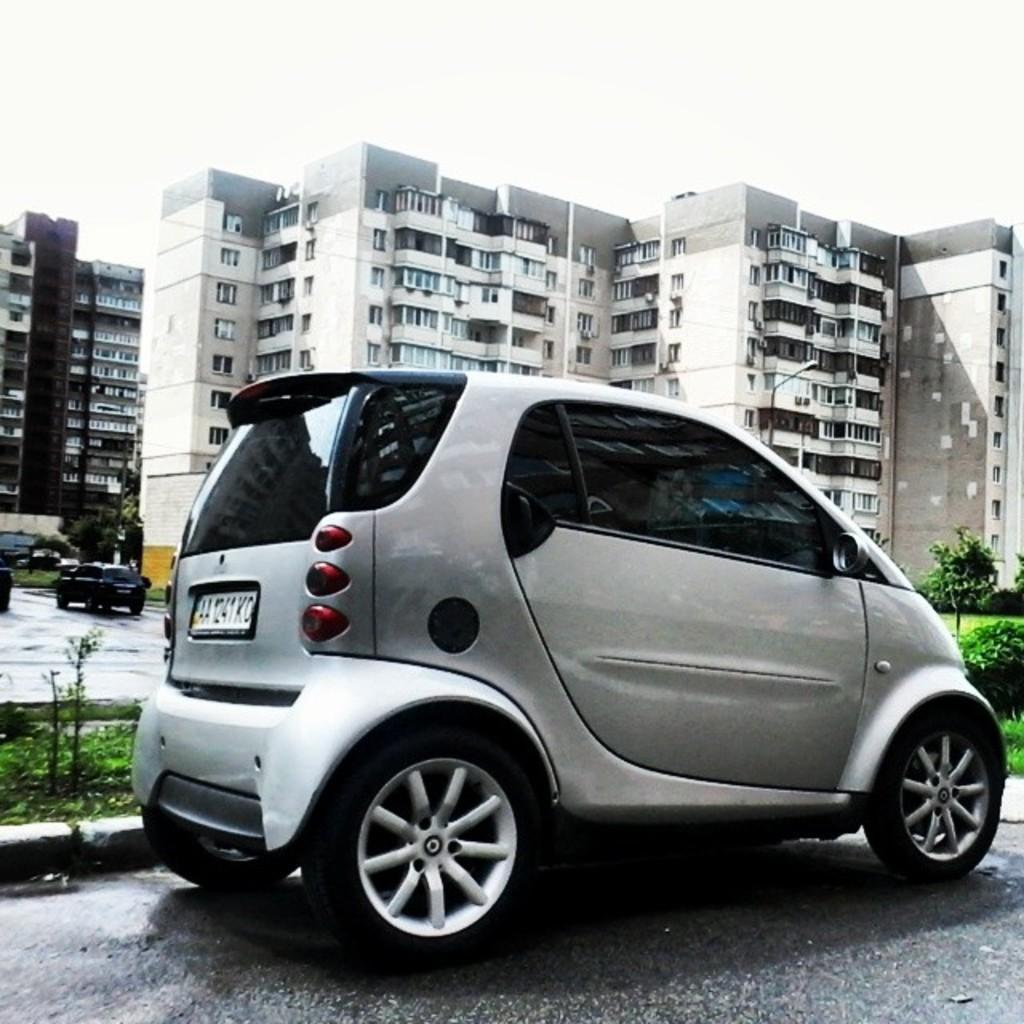Could you give a brief overview of what you see in this image? There is a gray color vehicle on the road. In the background, there is a vehicle on the road, there are buildings which are having glass windows, there are plants, there is grass and there is sky. 